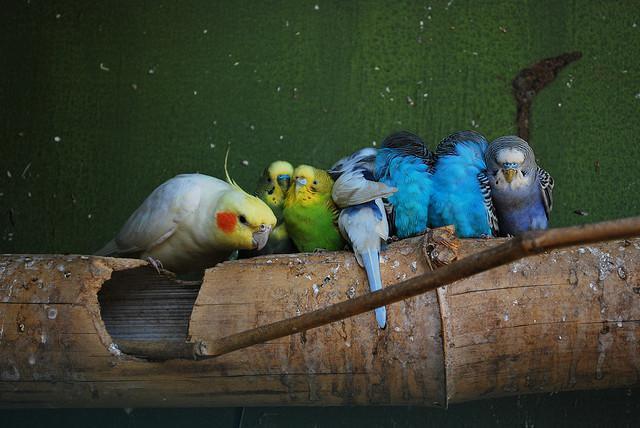What type of bird is the one on the far left?
Make your selection from the four choices given to correctly answer the question.
Options: Toucan, cockatiel, parrot, dove. Cockatiel. 